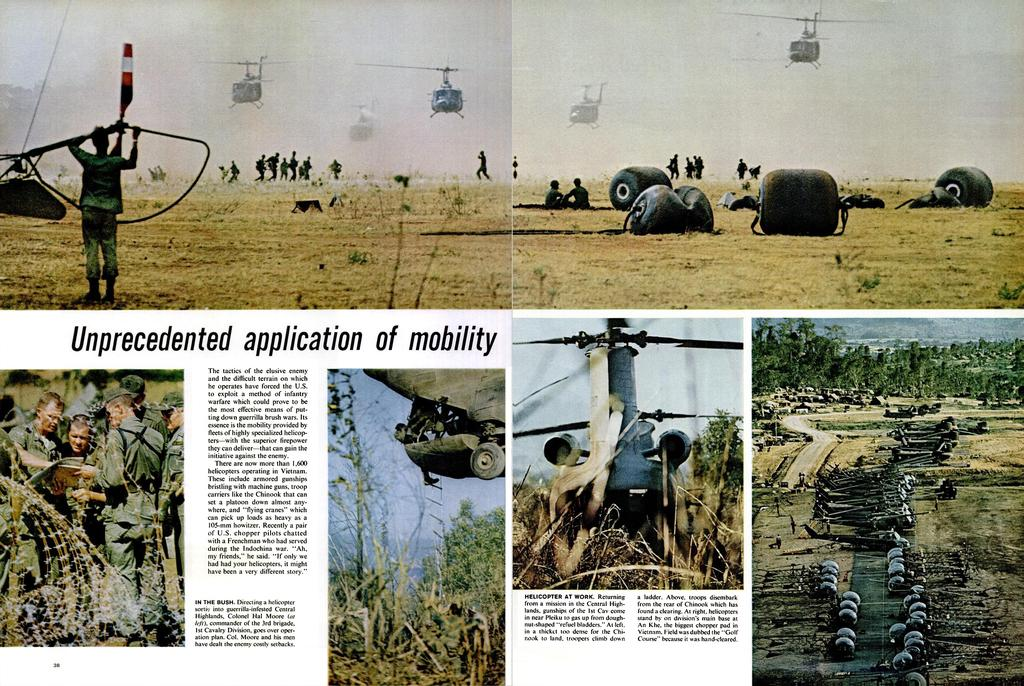What type of artwork is depicted in the image? The image is a collage. What type of printed material can be seen in the collage? There are newspaper clippings in the image. What else can be seen in the collage besides newspaper clippings? There are photos in the image. What is happening in the photos? Helicopters are present in the photos, and people are visible in the photos as well. Are there any other objects present in the photos? Yes, there are other objects in the photos. What type of quartz is used as a border for the collage? There is no quartz present in the image; it is a collage made up of newspaper clippings and photos. What type of leather is visible in the collage? There is no leather present in the image; it is a collage made up of newspaper clippings and photos. 